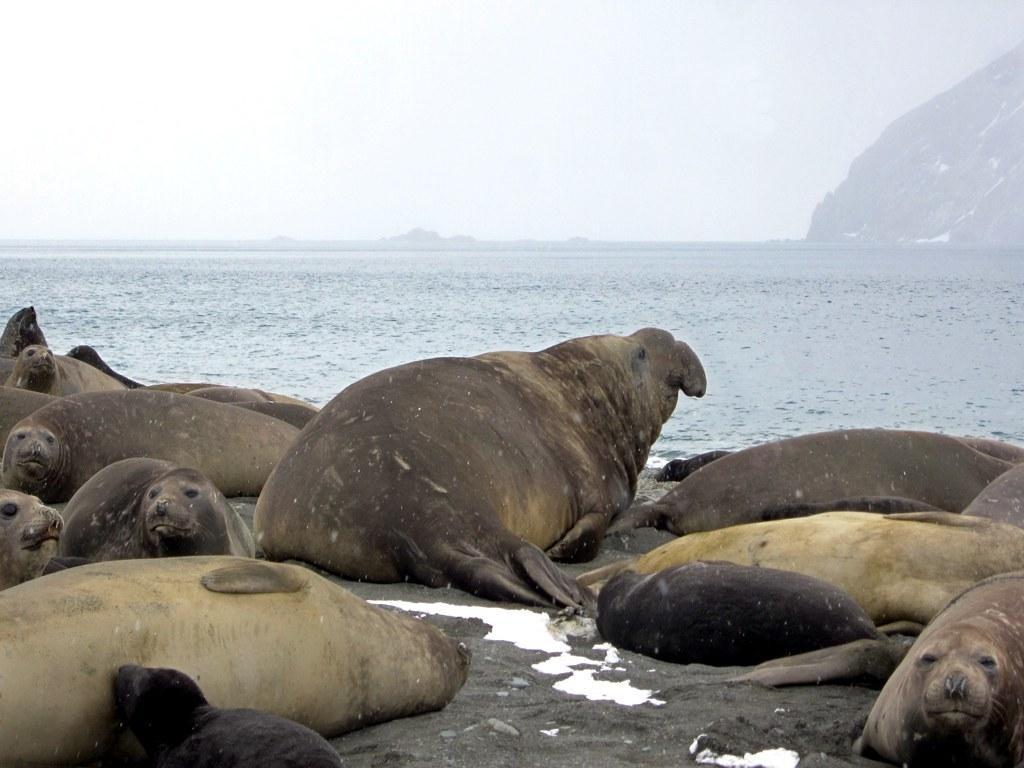Can you describe this image briefly? These are the seals, this is water, at the top it's a cloudy sky. 